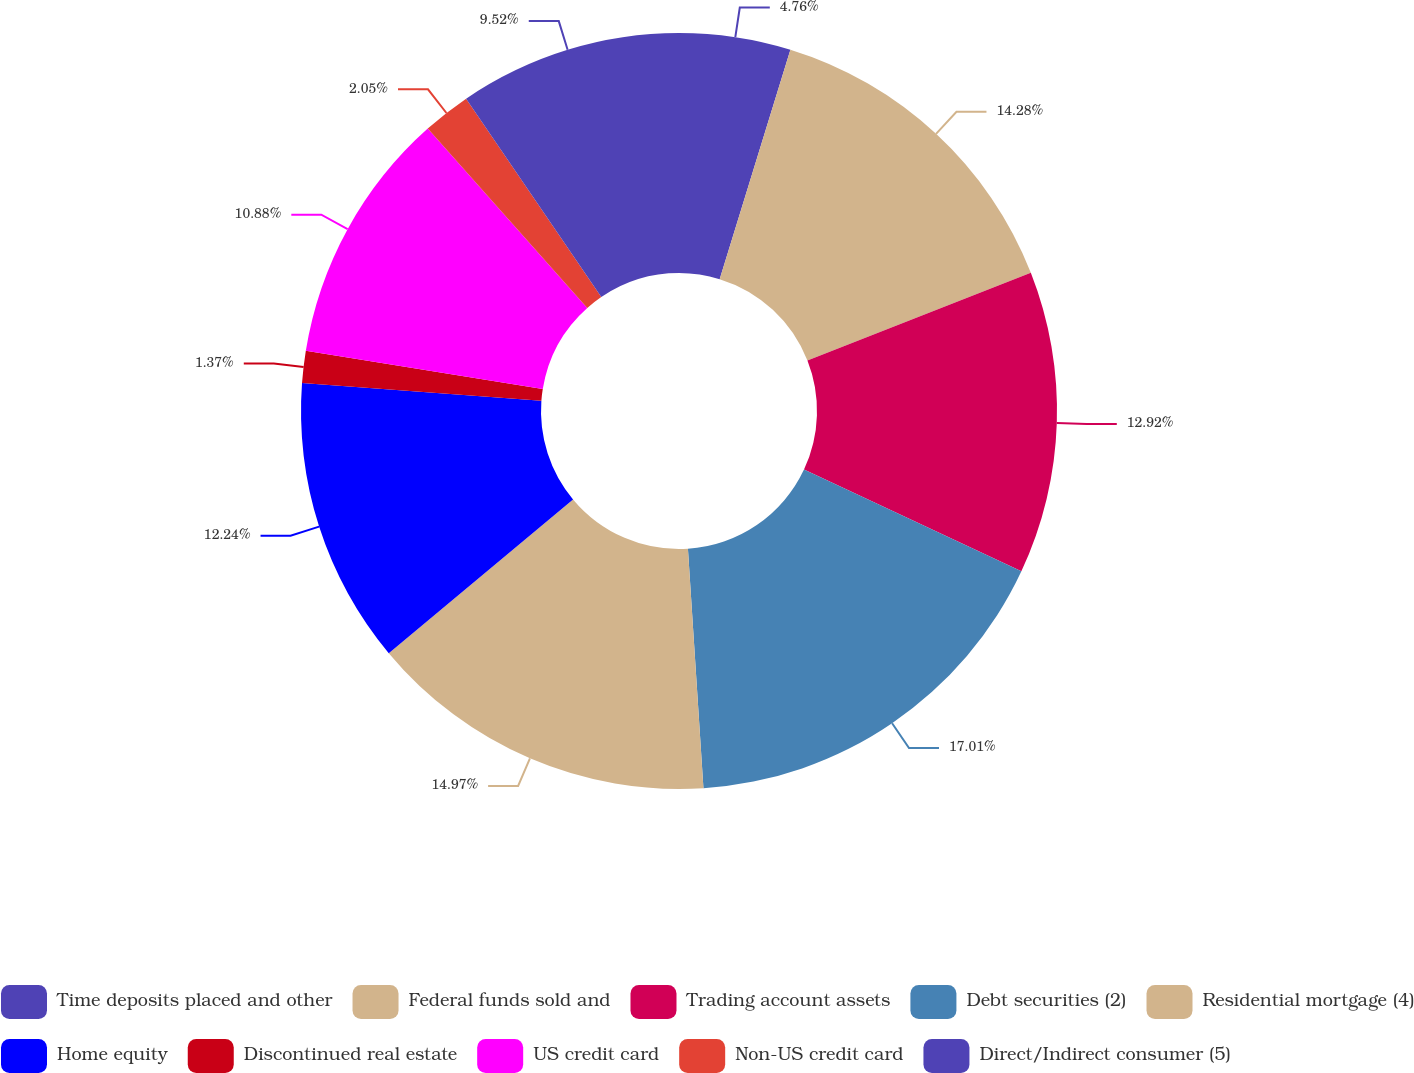<chart> <loc_0><loc_0><loc_500><loc_500><pie_chart><fcel>Time deposits placed and other<fcel>Federal funds sold and<fcel>Trading account assets<fcel>Debt securities (2)<fcel>Residential mortgage (4)<fcel>Home equity<fcel>Discontinued real estate<fcel>US credit card<fcel>Non-US credit card<fcel>Direct/Indirect consumer (5)<nl><fcel>4.76%<fcel>14.28%<fcel>12.92%<fcel>17.0%<fcel>14.96%<fcel>12.24%<fcel>1.37%<fcel>10.88%<fcel>2.05%<fcel>9.52%<nl></chart> 